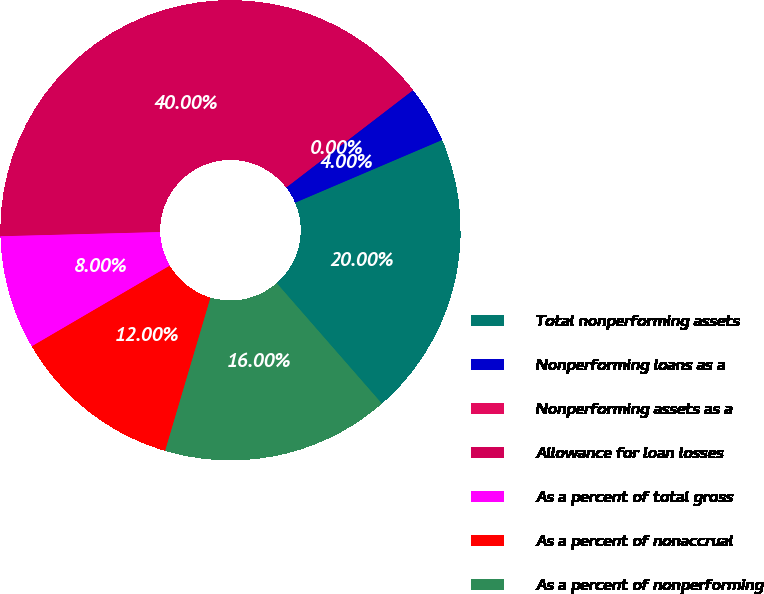<chart> <loc_0><loc_0><loc_500><loc_500><pie_chart><fcel>Total nonperforming assets<fcel>Nonperforming loans as a<fcel>Nonperforming assets as a<fcel>Allowance for loan losses<fcel>As a percent of total gross<fcel>As a percent of nonaccrual<fcel>As a percent of nonperforming<nl><fcel>20.0%<fcel>4.0%<fcel>0.0%<fcel>40.0%<fcel>8.0%<fcel>12.0%<fcel>16.0%<nl></chart> 